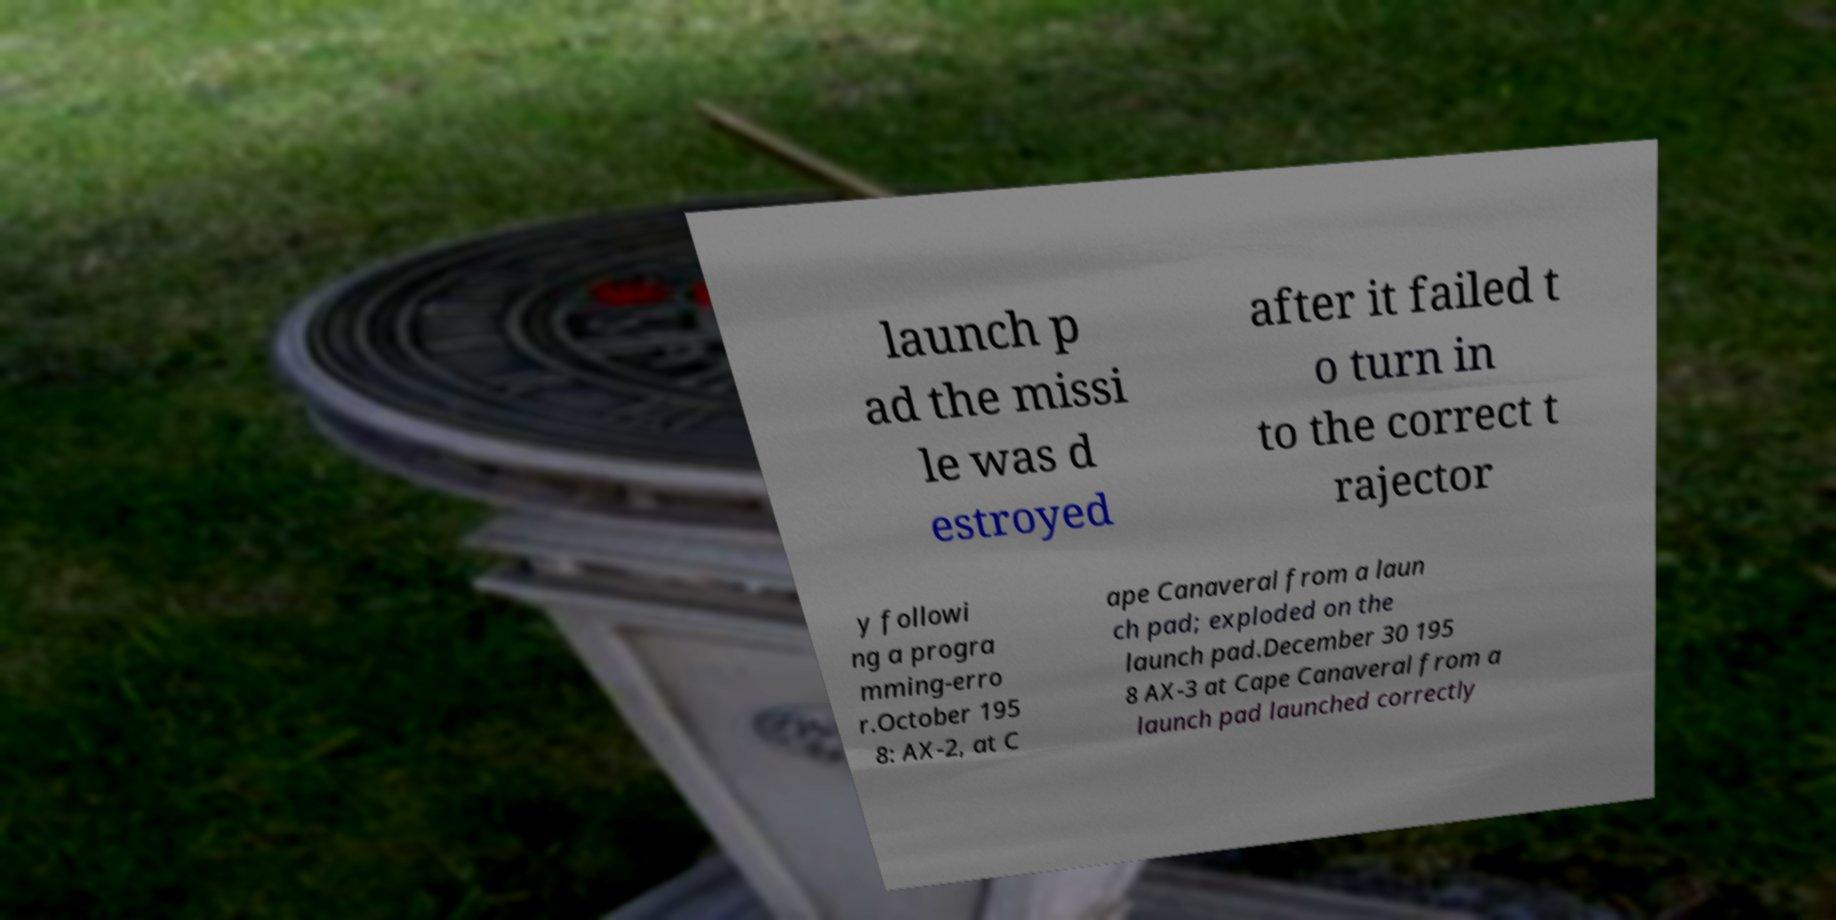I need the written content from this picture converted into text. Can you do that? launch p ad the missi le was d estroyed after it failed t o turn in to the correct t rajector y followi ng a progra mming-erro r.October 195 8: AX-2, at C ape Canaveral from a laun ch pad; exploded on the launch pad.December 30 195 8 AX-3 at Cape Canaveral from a launch pad launched correctly 